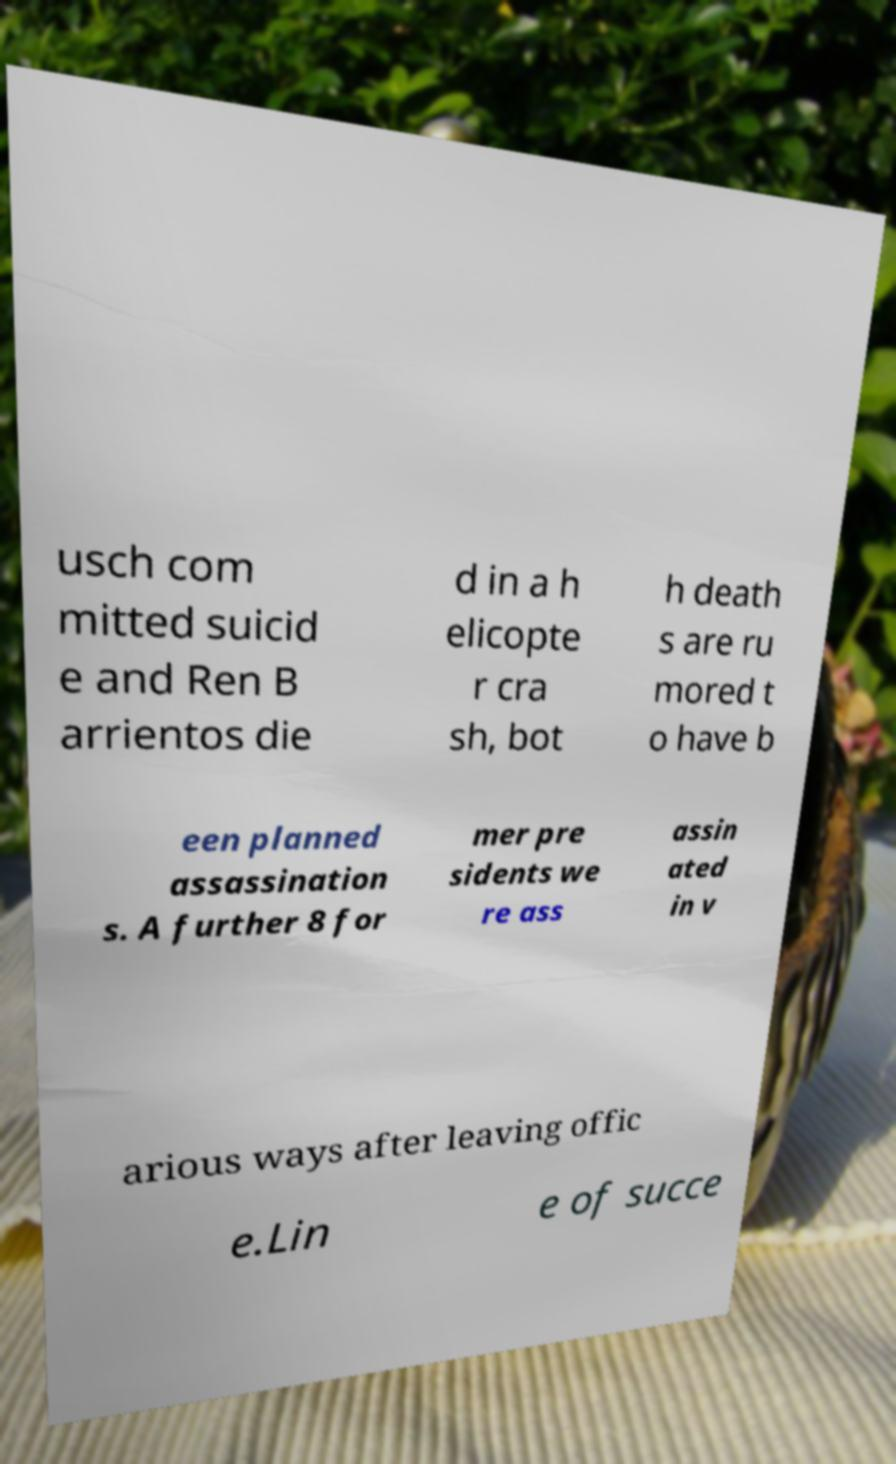What messages or text are displayed in this image? I need them in a readable, typed format. usch com mitted suicid e and Ren B arrientos die d in a h elicopte r cra sh, bot h death s are ru mored t o have b een planned assassination s. A further 8 for mer pre sidents we re ass assin ated in v arious ways after leaving offic e.Lin e of succe 